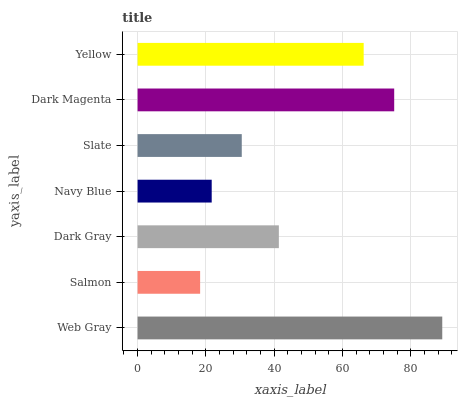Is Salmon the minimum?
Answer yes or no. Yes. Is Web Gray the maximum?
Answer yes or no. Yes. Is Dark Gray the minimum?
Answer yes or no. No. Is Dark Gray the maximum?
Answer yes or no. No. Is Dark Gray greater than Salmon?
Answer yes or no. Yes. Is Salmon less than Dark Gray?
Answer yes or no. Yes. Is Salmon greater than Dark Gray?
Answer yes or no. No. Is Dark Gray less than Salmon?
Answer yes or no. No. Is Dark Gray the high median?
Answer yes or no. Yes. Is Dark Gray the low median?
Answer yes or no. Yes. Is Navy Blue the high median?
Answer yes or no. No. Is Dark Magenta the low median?
Answer yes or no. No. 